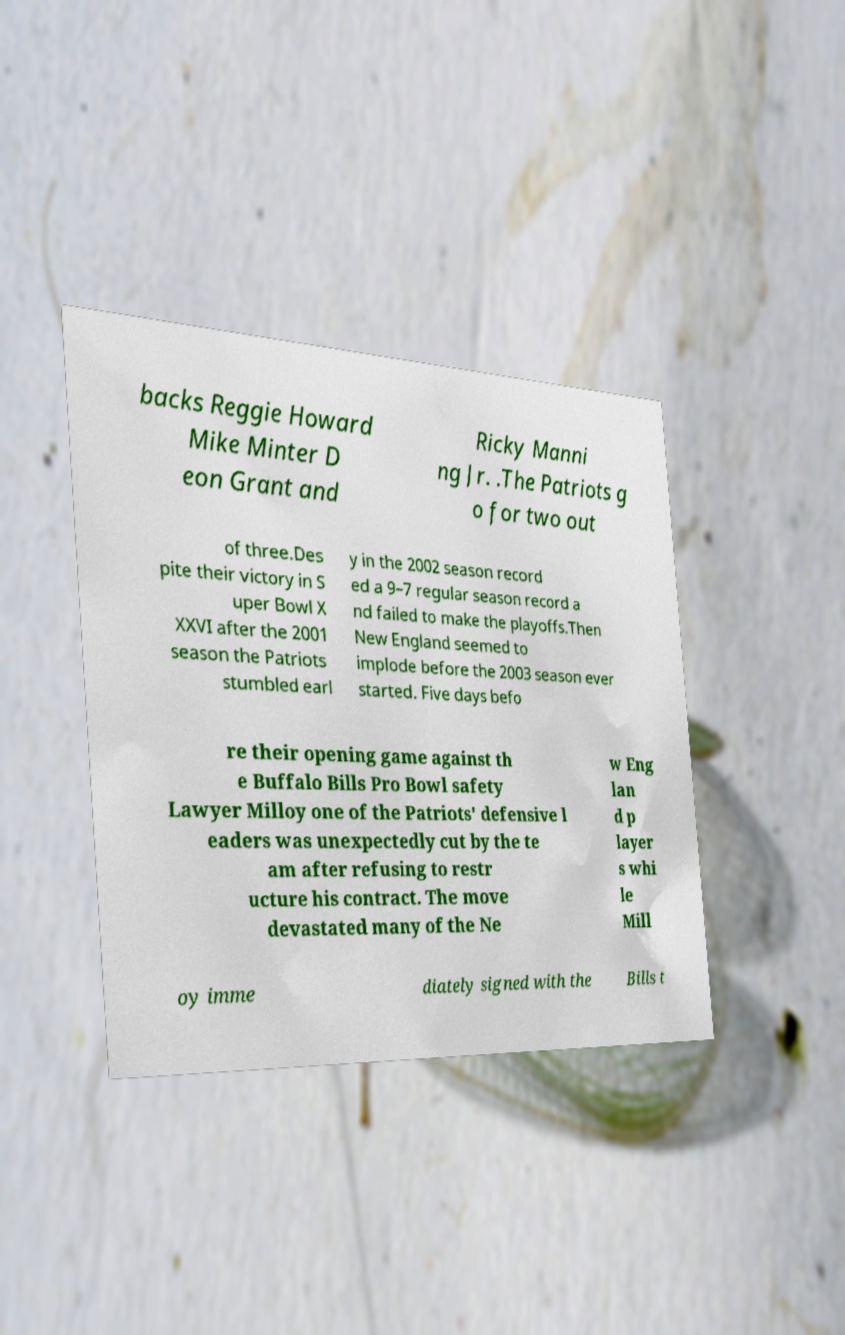I need the written content from this picture converted into text. Can you do that? backs Reggie Howard Mike Minter D eon Grant and Ricky Manni ng Jr. .The Patriots g o for two out of three.Des pite their victory in S uper Bowl X XXVI after the 2001 season the Patriots stumbled earl y in the 2002 season record ed a 9–7 regular season record a nd failed to make the playoffs.Then New England seemed to implode before the 2003 season ever started. Five days befo re their opening game against th e Buffalo Bills Pro Bowl safety Lawyer Milloy one of the Patriots' defensive l eaders was unexpectedly cut by the te am after refusing to restr ucture his contract. The move devastated many of the Ne w Eng lan d p layer s whi le Mill oy imme diately signed with the Bills t 